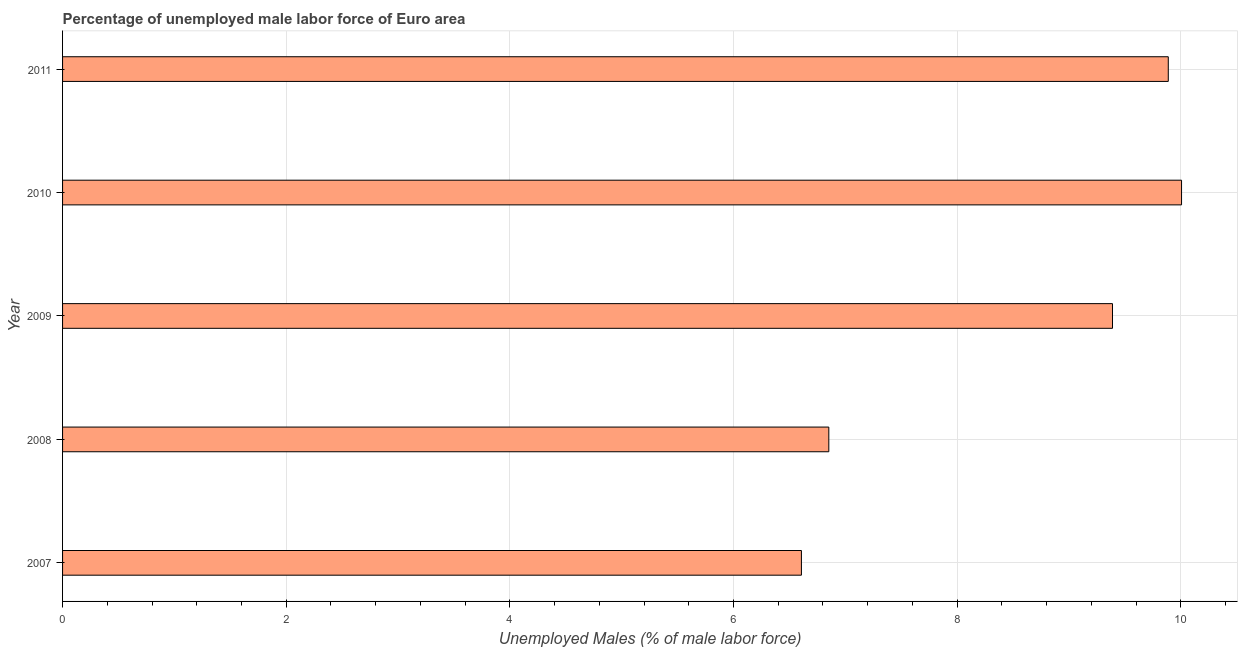Does the graph contain any zero values?
Provide a succinct answer. No. Does the graph contain grids?
Make the answer very short. Yes. What is the title of the graph?
Ensure brevity in your answer.  Percentage of unemployed male labor force of Euro area. What is the label or title of the X-axis?
Provide a short and direct response. Unemployed Males (% of male labor force). What is the total unemployed male labour force in 2011?
Keep it short and to the point. 9.89. Across all years, what is the maximum total unemployed male labour force?
Make the answer very short. 10.01. Across all years, what is the minimum total unemployed male labour force?
Provide a succinct answer. 6.61. In which year was the total unemployed male labour force maximum?
Make the answer very short. 2010. What is the sum of the total unemployed male labour force?
Your response must be concise. 42.75. What is the difference between the total unemployed male labour force in 2009 and 2011?
Keep it short and to the point. -0.5. What is the average total unemployed male labour force per year?
Offer a terse response. 8.55. What is the median total unemployed male labour force?
Offer a very short reply. 9.39. In how many years, is the total unemployed male labour force greater than 0.4 %?
Keep it short and to the point. 5. What is the ratio of the total unemployed male labour force in 2008 to that in 2011?
Ensure brevity in your answer.  0.69. Is the total unemployed male labour force in 2008 less than that in 2010?
Keep it short and to the point. Yes. What is the difference between the highest and the second highest total unemployed male labour force?
Provide a succinct answer. 0.12. Are all the bars in the graph horizontal?
Give a very brief answer. Yes. How many years are there in the graph?
Your response must be concise. 5. Are the values on the major ticks of X-axis written in scientific E-notation?
Your response must be concise. No. What is the Unemployed Males (% of male labor force) in 2007?
Provide a succinct answer. 6.61. What is the Unemployed Males (% of male labor force) in 2008?
Provide a short and direct response. 6.85. What is the Unemployed Males (% of male labor force) in 2009?
Make the answer very short. 9.39. What is the Unemployed Males (% of male labor force) of 2010?
Keep it short and to the point. 10.01. What is the Unemployed Males (% of male labor force) in 2011?
Your answer should be compact. 9.89. What is the difference between the Unemployed Males (% of male labor force) in 2007 and 2008?
Your answer should be very brief. -0.24. What is the difference between the Unemployed Males (% of male labor force) in 2007 and 2009?
Your response must be concise. -2.78. What is the difference between the Unemployed Males (% of male labor force) in 2007 and 2010?
Your response must be concise. -3.4. What is the difference between the Unemployed Males (% of male labor force) in 2007 and 2011?
Your answer should be compact. -3.28. What is the difference between the Unemployed Males (% of male labor force) in 2008 and 2009?
Make the answer very short. -2.54. What is the difference between the Unemployed Males (% of male labor force) in 2008 and 2010?
Your answer should be very brief. -3.15. What is the difference between the Unemployed Males (% of male labor force) in 2008 and 2011?
Give a very brief answer. -3.04. What is the difference between the Unemployed Males (% of male labor force) in 2009 and 2010?
Your answer should be compact. -0.62. What is the difference between the Unemployed Males (% of male labor force) in 2009 and 2011?
Offer a terse response. -0.5. What is the difference between the Unemployed Males (% of male labor force) in 2010 and 2011?
Ensure brevity in your answer.  0.12. What is the ratio of the Unemployed Males (% of male labor force) in 2007 to that in 2009?
Give a very brief answer. 0.7. What is the ratio of the Unemployed Males (% of male labor force) in 2007 to that in 2010?
Provide a succinct answer. 0.66. What is the ratio of the Unemployed Males (% of male labor force) in 2007 to that in 2011?
Give a very brief answer. 0.67. What is the ratio of the Unemployed Males (% of male labor force) in 2008 to that in 2009?
Provide a short and direct response. 0.73. What is the ratio of the Unemployed Males (% of male labor force) in 2008 to that in 2010?
Your answer should be very brief. 0.69. What is the ratio of the Unemployed Males (% of male labor force) in 2008 to that in 2011?
Your answer should be very brief. 0.69. What is the ratio of the Unemployed Males (% of male labor force) in 2009 to that in 2010?
Offer a very short reply. 0.94. What is the ratio of the Unemployed Males (% of male labor force) in 2009 to that in 2011?
Make the answer very short. 0.95. What is the ratio of the Unemployed Males (% of male labor force) in 2010 to that in 2011?
Ensure brevity in your answer.  1.01. 